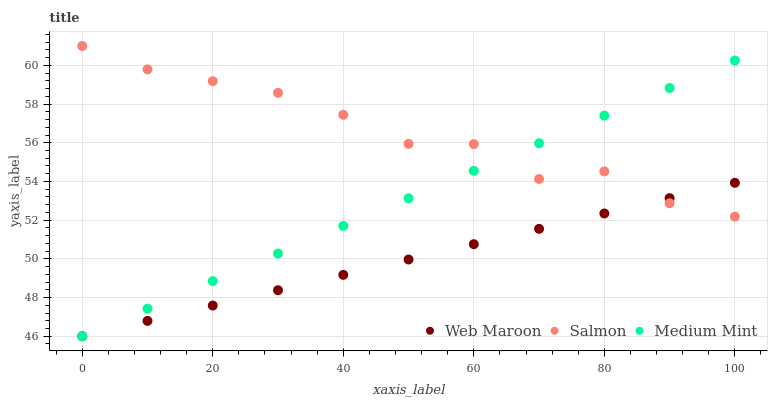Does Web Maroon have the minimum area under the curve?
Answer yes or no. Yes. Does Salmon have the maximum area under the curve?
Answer yes or no. Yes. Does Salmon have the minimum area under the curve?
Answer yes or no. No. Does Web Maroon have the maximum area under the curve?
Answer yes or no. No. Is Web Maroon the smoothest?
Answer yes or no. Yes. Is Salmon the roughest?
Answer yes or no. Yes. Is Salmon the smoothest?
Answer yes or no. No. Is Web Maroon the roughest?
Answer yes or no. No. Does Medium Mint have the lowest value?
Answer yes or no. Yes. Does Salmon have the lowest value?
Answer yes or no. No. Does Salmon have the highest value?
Answer yes or no. Yes. Does Web Maroon have the highest value?
Answer yes or no. No. Does Salmon intersect Web Maroon?
Answer yes or no. Yes. Is Salmon less than Web Maroon?
Answer yes or no. No. Is Salmon greater than Web Maroon?
Answer yes or no. No. 